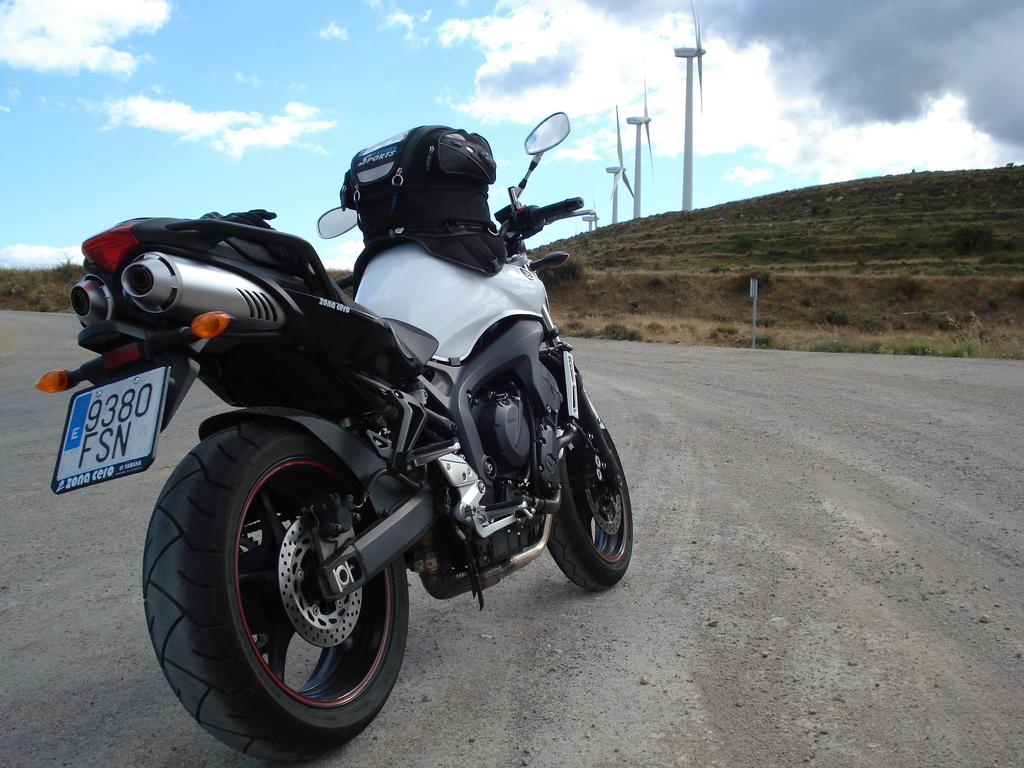What is the main subject of the image? The main subject of the image is a motorbike. Where is the motorbike located? The motorbike is on the road. What can be seen in the background of the image? In the background of the image, there are plants, windmills, and the sky. What is the condition of the sky in the image? The sky is visible in the background of the image, and clouds are present. What type of cable can be seen connecting the windmills in the image? There is no cable connecting the windmills in the image; they are separate structures in the background. Is there a party happening near the motorbike in the image? There is no indication of a party in the image; it only features a motorbike on the road and the background elements. 